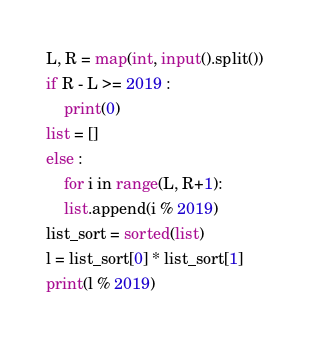<code> <loc_0><loc_0><loc_500><loc_500><_Python_>L, R = map(int, input().split())
if R - L >= 2019 :
    print(0)
list = []
else :
    for i in range(L, R+1):
    list.append(i % 2019)
list_sort = sorted(list)
l = list_sort[0] * list_sort[1]
print(l % 2019)
</code> 